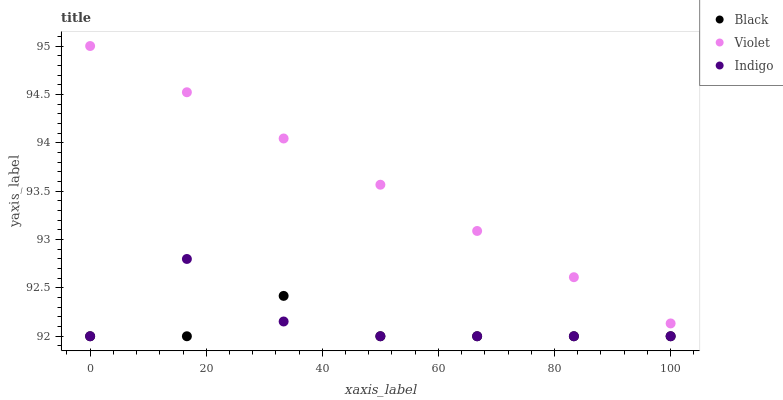Does Black have the minimum area under the curve?
Answer yes or no. Yes. Does Violet have the maximum area under the curve?
Answer yes or no. Yes. Does Violet have the minimum area under the curve?
Answer yes or no. No. Does Black have the maximum area under the curve?
Answer yes or no. No. Is Violet the smoothest?
Answer yes or no. Yes. Is Indigo the roughest?
Answer yes or no. Yes. Is Black the smoothest?
Answer yes or no. No. Is Black the roughest?
Answer yes or no. No. Does Indigo have the lowest value?
Answer yes or no. Yes. Does Violet have the lowest value?
Answer yes or no. No. Does Violet have the highest value?
Answer yes or no. Yes. Does Black have the highest value?
Answer yes or no. No. Is Black less than Violet?
Answer yes or no. Yes. Is Violet greater than Black?
Answer yes or no. Yes. Does Indigo intersect Black?
Answer yes or no. Yes. Is Indigo less than Black?
Answer yes or no. No. Is Indigo greater than Black?
Answer yes or no. No. Does Black intersect Violet?
Answer yes or no. No. 